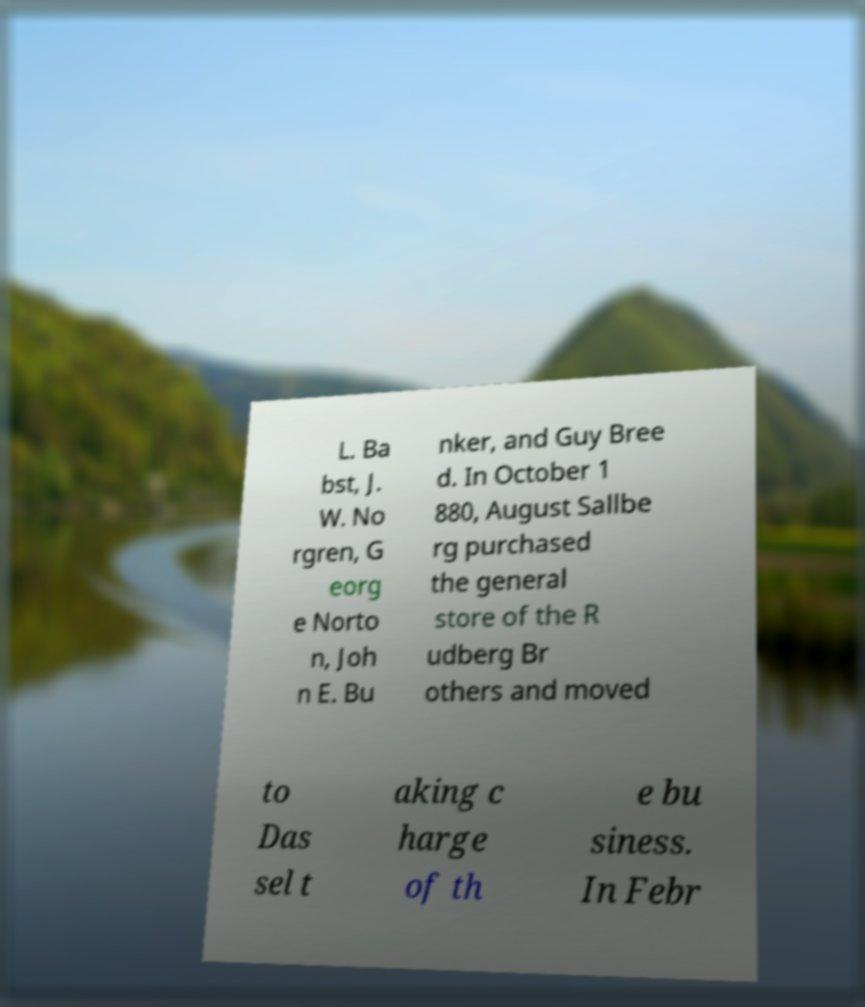There's text embedded in this image that I need extracted. Can you transcribe it verbatim? L. Ba bst, J. W. No rgren, G eorg e Norto n, Joh n E. Bu nker, and Guy Bree d. In October 1 880, August Sallbe rg purchased the general store of the R udberg Br others and moved to Das sel t aking c harge of th e bu siness. In Febr 